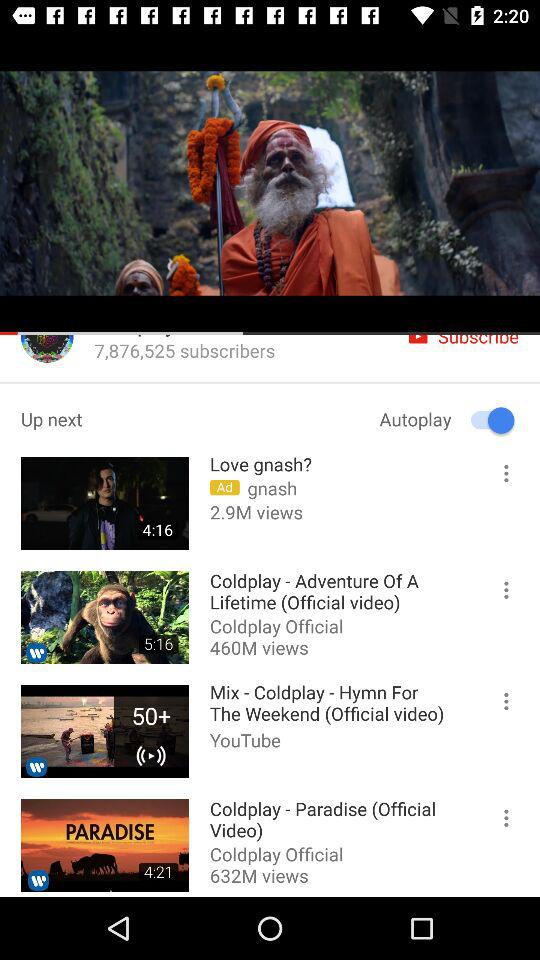What is the duration of the "Coldplay - Adventure Of A Lifetime" video? The duration of the video is 5:16. 